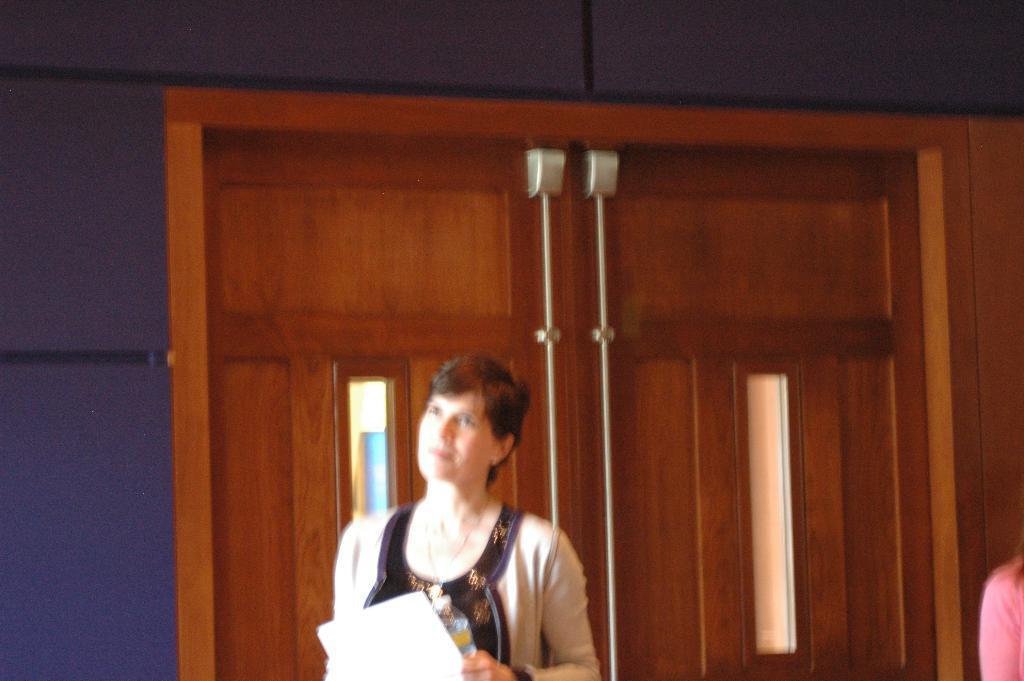Please provide a concise description of this image. In the center of the image there is a woman standing with water bottle and paper. In the background there is a door and wall. 